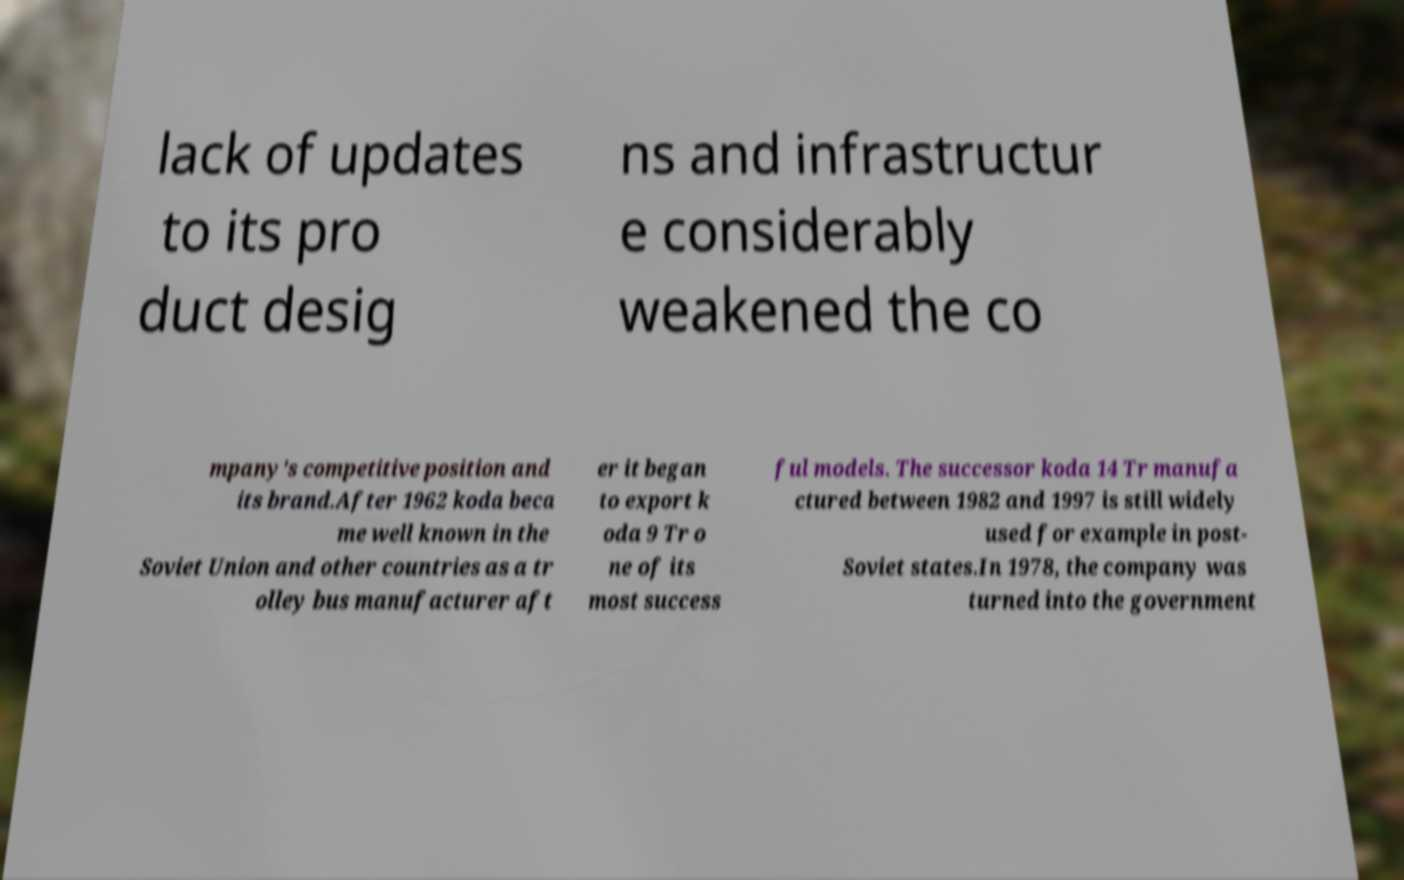For documentation purposes, I need the text within this image transcribed. Could you provide that? lack of updates to its pro duct desig ns and infrastructur e considerably weakened the co mpany's competitive position and its brand.After 1962 koda beca me well known in the Soviet Union and other countries as a tr olley bus manufacturer aft er it began to export k oda 9 Tr o ne of its most success ful models. The successor koda 14 Tr manufa ctured between 1982 and 1997 is still widely used for example in post- Soviet states.In 1978, the company was turned into the government 